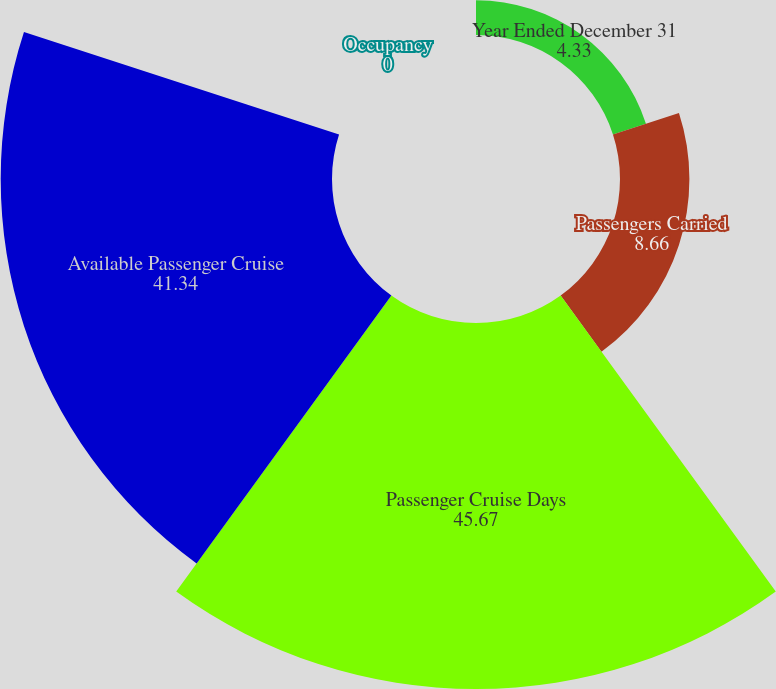<chart> <loc_0><loc_0><loc_500><loc_500><pie_chart><fcel>Year Ended December 31<fcel>Passengers Carried<fcel>Passenger Cruise Days<fcel>Available Passenger Cruise<fcel>Occupancy<nl><fcel>4.33%<fcel>8.66%<fcel>45.67%<fcel>41.34%<fcel>0.0%<nl></chart> 